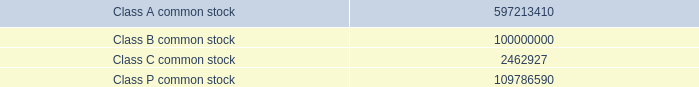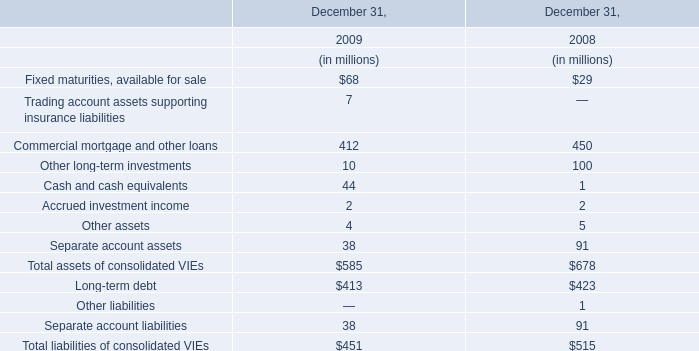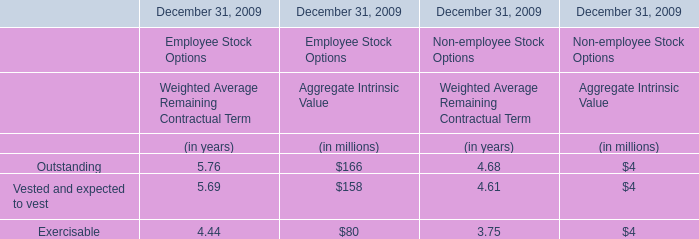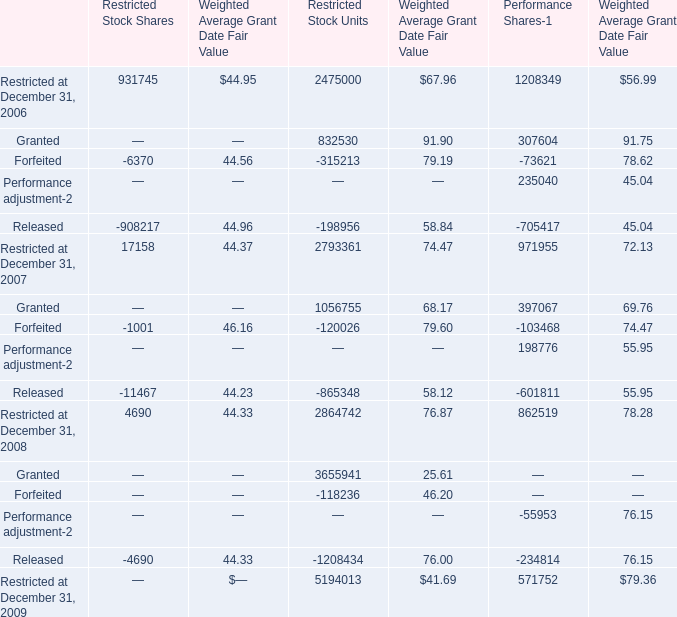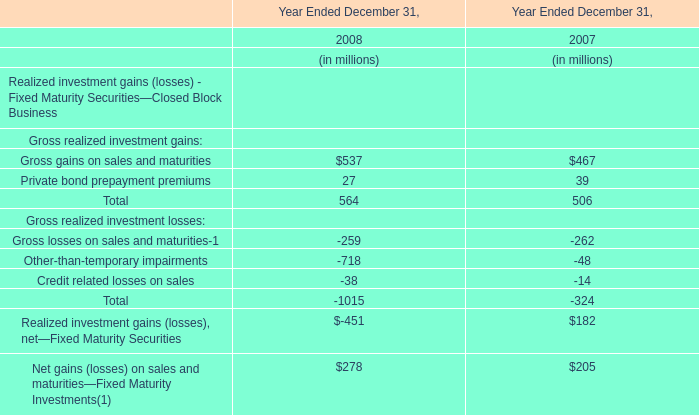What is the percentage of Outstanding in relation to the total in 2009 for Aggregate Intrinsic Value of Employee Stock Options ? 
Computations: (166 / ((166 + 158) + 80))
Answer: 0.41089. 